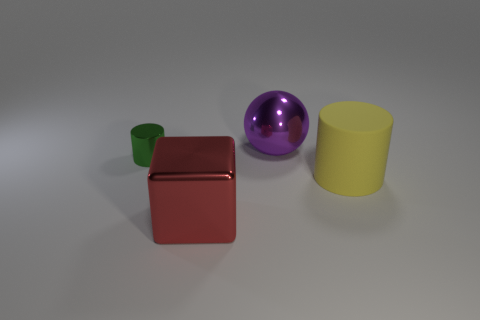Add 2 metal cubes. How many objects exist? 6 Subtract all cubes. How many objects are left? 3 Subtract 0 green cubes. How many objects are left? 4 Subtract all tiny green metal spheres. Subtract all small cylinders. How many objects are left? 3 Add 4 big matte things. How many big matte things are left? 5 Add 1 blue matte cylinders. How many blue matte cylinders exist? 1 